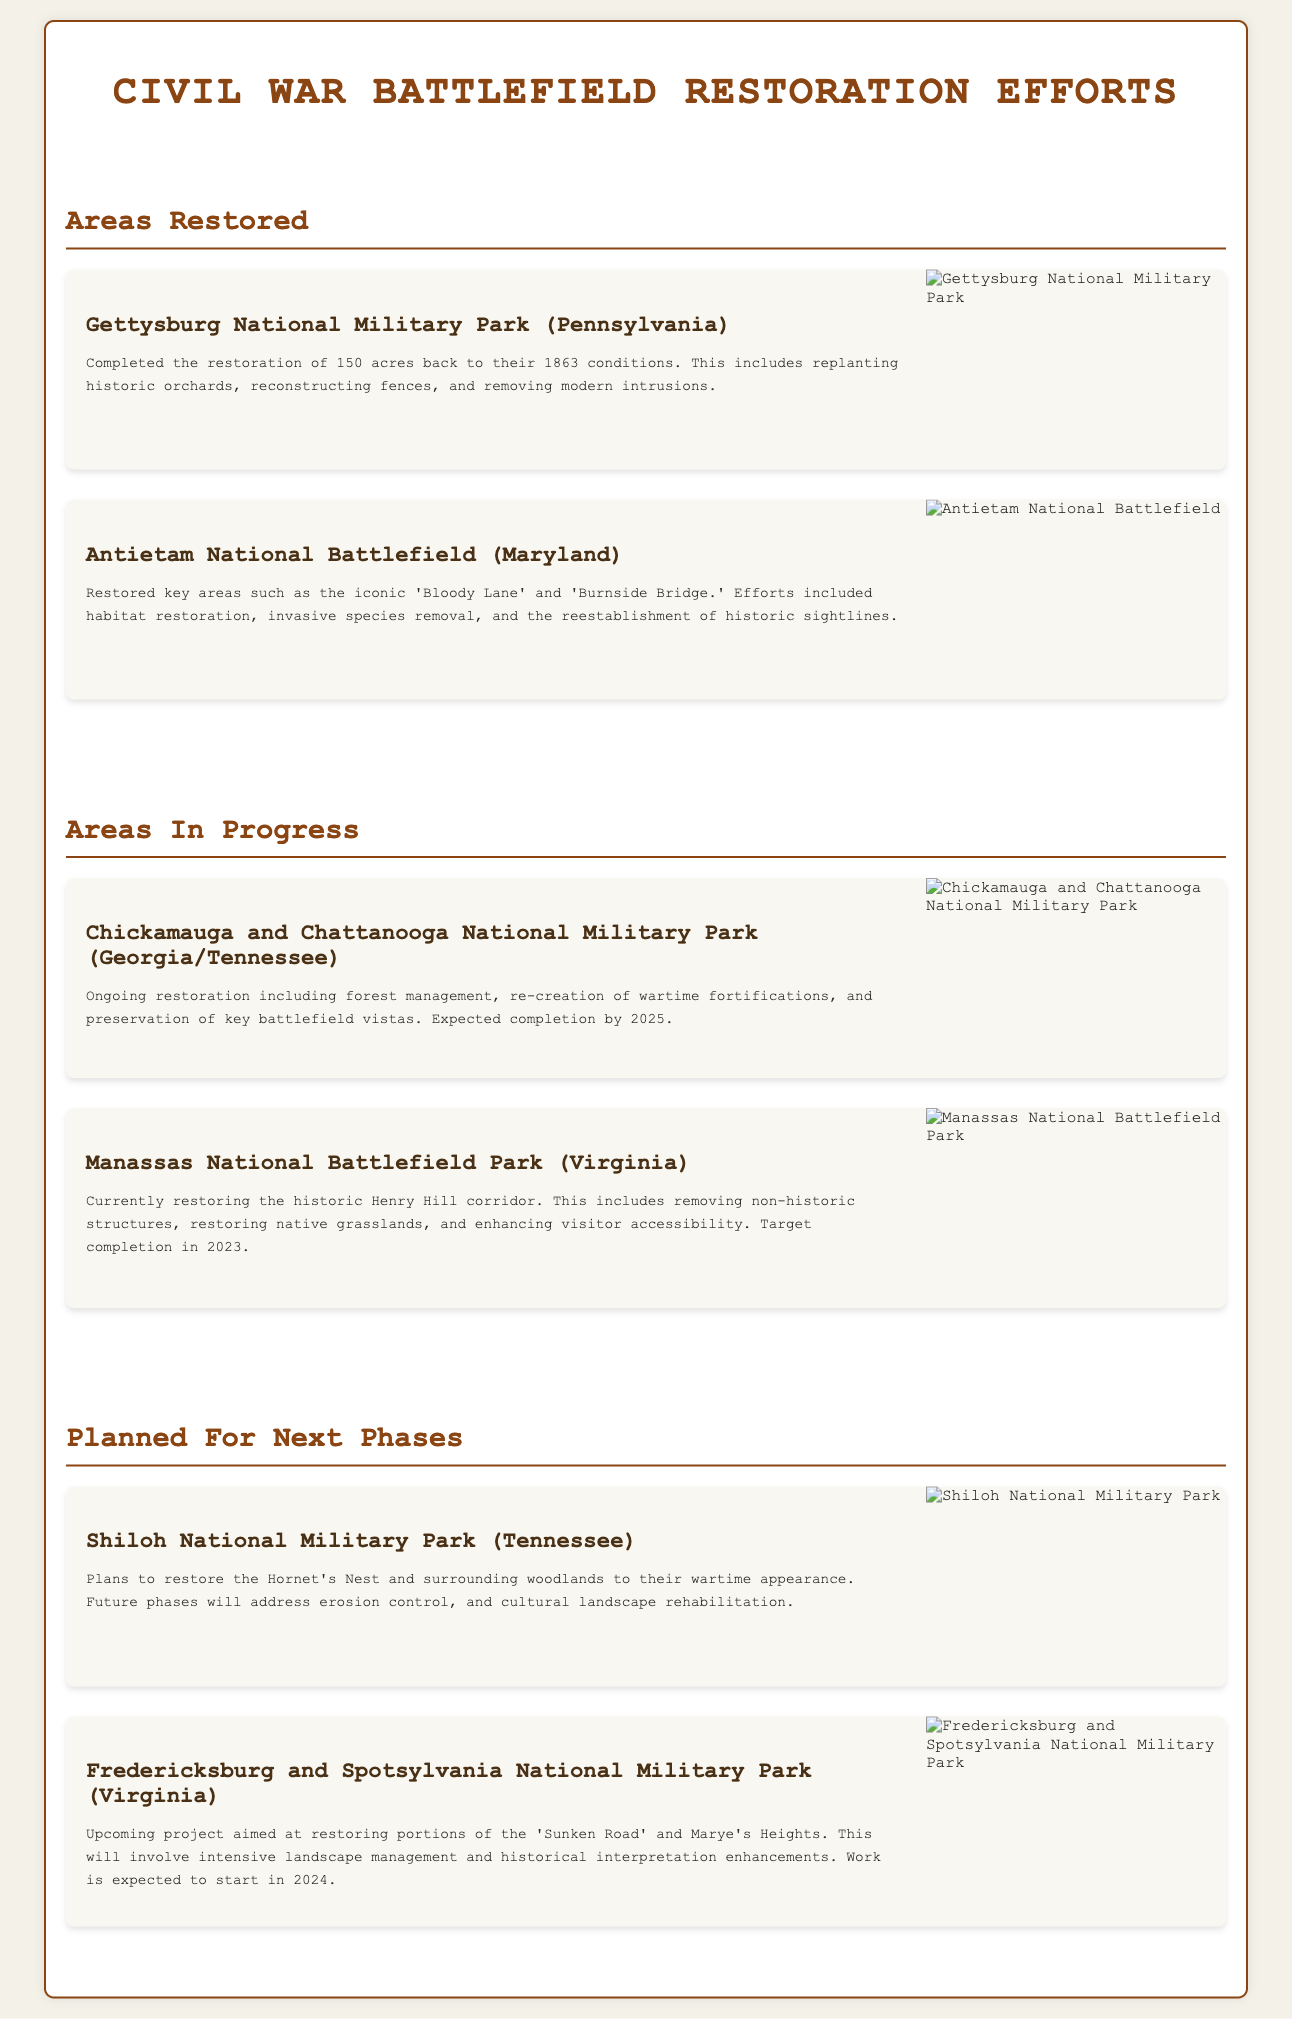What area was restored at Gettysburg National Military Park? The document states that Gettysburg National Military Park restored 150 acres back to their 1863 conditions.
Answer: 150 acres Which historical bridge was restored at Antietam National Battlefield? The document mentions that the restoration efforts included the iconic 'Burnside Bridge.'
Answer: Burnside Bridge What is the expected completion year for the restoration at Chickamauga and Chattanooga National Military Park? According to the document, the expected completion year for the restoration is 2025.
Answer: 2025 What type of management is currently taking place at Manassas National Battlefield Park? The document indicates that historic structures are being removed and grasslands restored as part of ongoing restoration work.
Answer: Removing non-historic structures What is planned for restoration at Shiloh National Military Park? The document specifies plans to restore the Hornet's Nest and surrounding woodlands.
Answer: Hornet's Nest Which section involves portions of the 'Sunken Road' for restoration? The document notes that Fredericksburg and Spotsylvania National Military Park will restore portions of the 'Sunken Road.'
Answer: Fredericksburg and Spotsylvania National Military Park How many areas are listed as 'in progress'? The document indicates there are two areas currently listed as 'in progress.'
Answer: 2 What type of effort is being focused on at Antietam regarding habitat? The document describes habitat restoration efforts as part of the work done at Antietam.
Answer: Habitat restoration What is unique about the document type presented? The document is a geographic infographic focusing on historical restoration efforts at Civil War battlefields.
Answer: Geographic infographic 